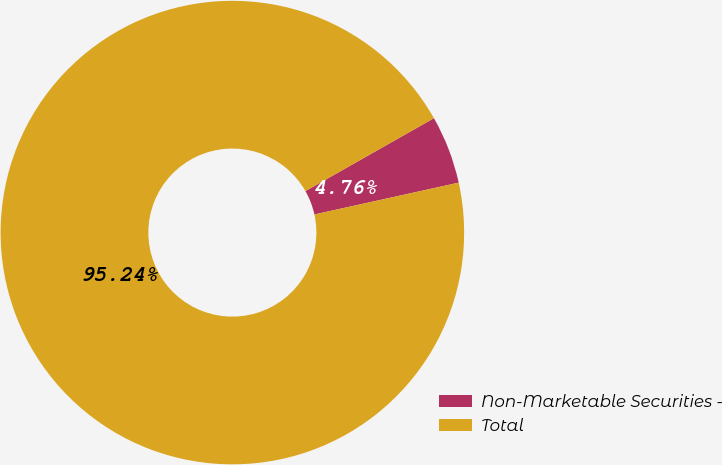Convert chart. <chart><loc_0><loc_0><loc_500><loc_500><pie_chart><fcel>Non-Marketable Securities -<fcel>Total<nl><fcel>4.76%<fcel>95.24%<nl></chart> 